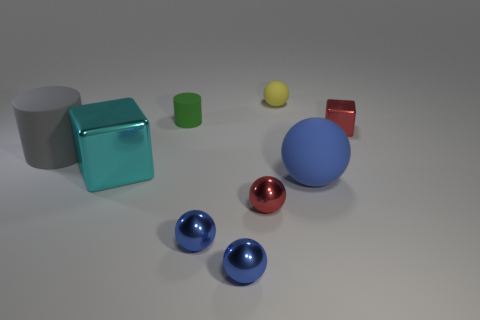Which two objects are closest to each other? The two blue balls appear to be closest to each other in comparison to any other pair of objects in this image. 